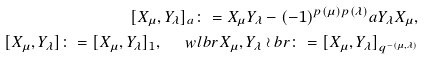<formula> <loc_0><loc_0><loc_500><loc_500>[ X _ { \mu } , Y _ { \lambda } ] _ { a } \colon = X _ { \mu } Y _ { \lambda } - ( - 1 ) ^ { p ( \mu ) p ( \lambda ) } a Y _ { \lambda } X _ { \mu } , \\ [ X _ { \mu } , Y _ { \lambda } ] \colon = [ X _ { \mu } , Y _ { \lambda } ] _ { 1 } , \quad \ w l b r X _ { \mu } , Y _ { \lambda } \wr b r \colon = [ X _ { \mu } , Y _ { \lambda } ] _ { q ^ { - ( \mu , \lambda ) } }</formula> 